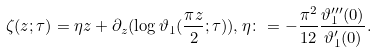<formula> <loc_0><loc_0><loc_500><loc_500>\zeta ( z ; \tau ) = \eta z + \partial _ { z } ( \log \vartheta _ { 1 } ( \frac { \pi z } 2 ; \tau ) ) , \eta \colon = - \frac { \pi ^ { 2 } } { 1 2 } \frac { \vartheta _ { 1 } ^ { \prime \prime \prime } ( 0 ) } { \vartheta _ { 1 } ^ { \prime } ( 0 ) } .</formula> 